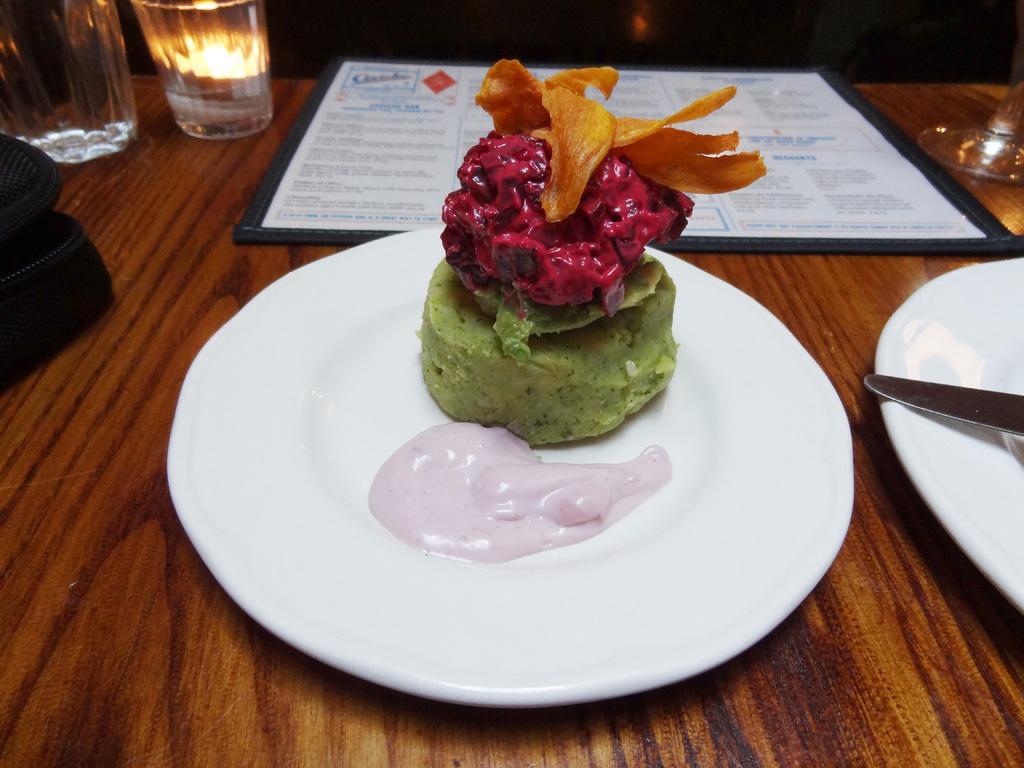Describe this image in one or two sentences. In this image there is a glass and object on the left corner. There is a plate, chalk and glass on the right corner. There is a table at the bottom. There is a food item on the plate in the foreground. And there is a menu card in the background. 